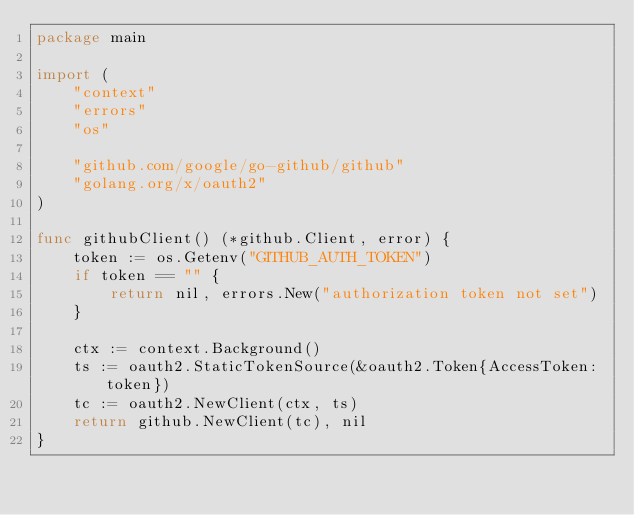Convert code to text. <code><loc_0><loc_0><loc_500><loc_500><_Go_>package main

import (
	"context"
	"errors"
	"os"

	"github.com/google/go-github/github"
	"golang.org/x/oauth2"
)

func githubClient() (*github.Client, error) {
	token := os.Getenv("GITHUB_AUTH_TOKEN")
	if token == "" {
		return nil, errors.New("authorization token not set")
	}

	ctx := context.Background()
	ts := oauth2.StaticTokenSource(&oauth2.Token{AccessToken: token})
	tc := oauth2.NewClient(ctx, ts)
	return github.NewClient(tc), nil
}
</code> 